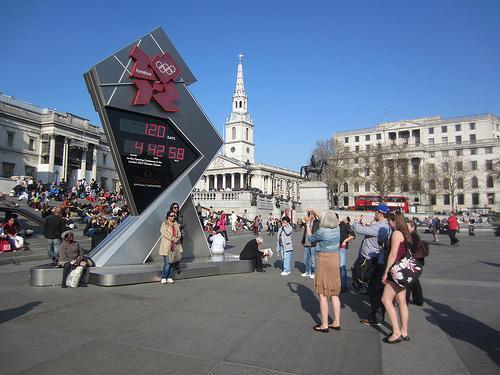How many people are getting their picture taken?
Give a very brief answer. 2. How many people are sitting on the sign?
Give a very brief answer. 3. 